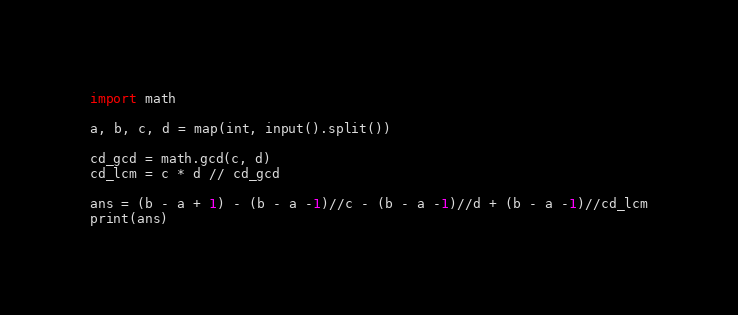<code> <loc_0><loc_0><loc_500><loc_500><_Python_>import math

a, b, c, d = map(int, input().split())

cd_gcd = math.gcd(c, d)
cd_lcm = c * d // cd_gcd

ans = (b - a + 1) - (b - a -1)//c - (b - a -1)//d + (b - a -1)//cd_lcm
print(ans)</code> 